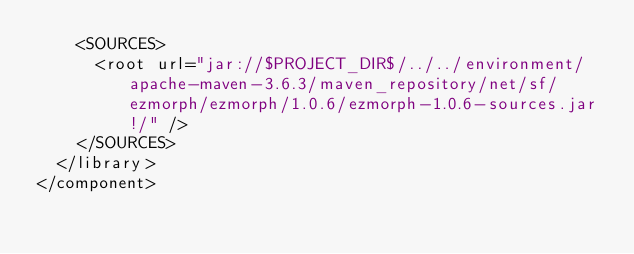<code> <loc_0><loc_0><loc_500><loc_500><_XML_>    <SOURCES>
      <root url="jar://$PROJECT_DIR$/../../environment/apache-maven-3.6.3/maven_repository/net/sf/ezmorph/ezmorph/1.0.6/ezmorph-1.0.6-sources.jar!/" />
    </SOURCES>
  </library>
</component></code> 